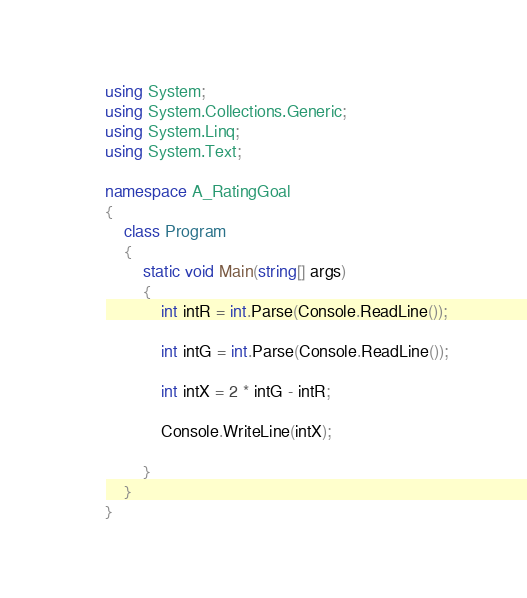<code> <loc_0><loc_0><loc_500><loc_500><_C#_>using System;
using System.Collections.Generic;
using System.Linq;
using System.Text;

namespace A_RatingGoal
{
    class Program
    {
        static void Main(string[] args)
        {
            int intR = int.Parse(Console.ReadLine());

            int intG = int.Parse(Console.ReadLine());

            int intX = 2 * intG - intR;

            Console.WriteLine(intX);

        }
    }
}
</code> 